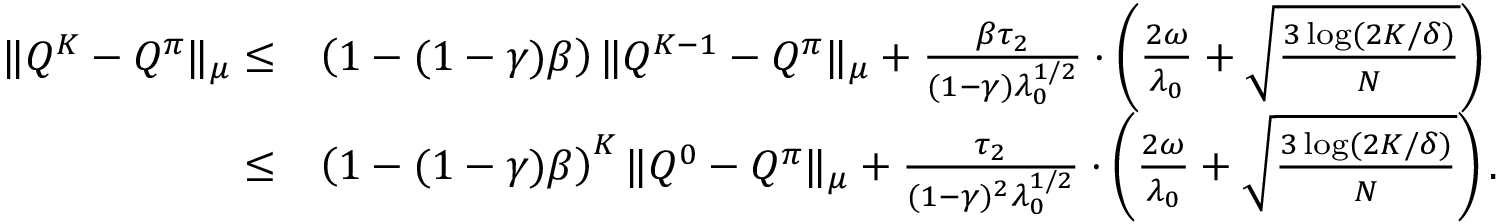Convert formula to latex. <formula><loc_0><loc_0><loc_500><loc_500>\begin{array} { r l } { \| Q ^ { K } - Q ^ { \pi } \| _ { \mu } \leq } & { \left ( 1 - ( 1 - \gamma ) \beta \right ) \| Q ^ { K - 1 } - Q ^ { \pi } \| _ { \mu } + \frac { \beta \tau _ { 2 } } { ( 1 - \gamma ) \lambda _ { 0 } ^ { 1 / 2 } } \cdot \left ( \frac { 2 \omega } { \lambda _ { 0 } } + \sqrt { \frac { 3 \log ( 2 K / \delta ) } { N } } \right ) } \\ { \leq } & { \left ( 1 - ( 1 - \gamma ) \beta \right ) ^ { K } \| Q ^ { 0 } - Q ^ { \pi } \| _ { \mu } + \frac { \tau _ { 2 } } { ( 1 - \gamma ) ^ { 2 } \lambda _ { 0 } ^ { 1 / 2 } } \cdot \left ( \frac { 2 \omega } { \lambda _ { 0 } } + \sqrt { \frac { 3 \log ( 2 K / \delta ) } { N } } \right ) . } \end{array}</formula> 